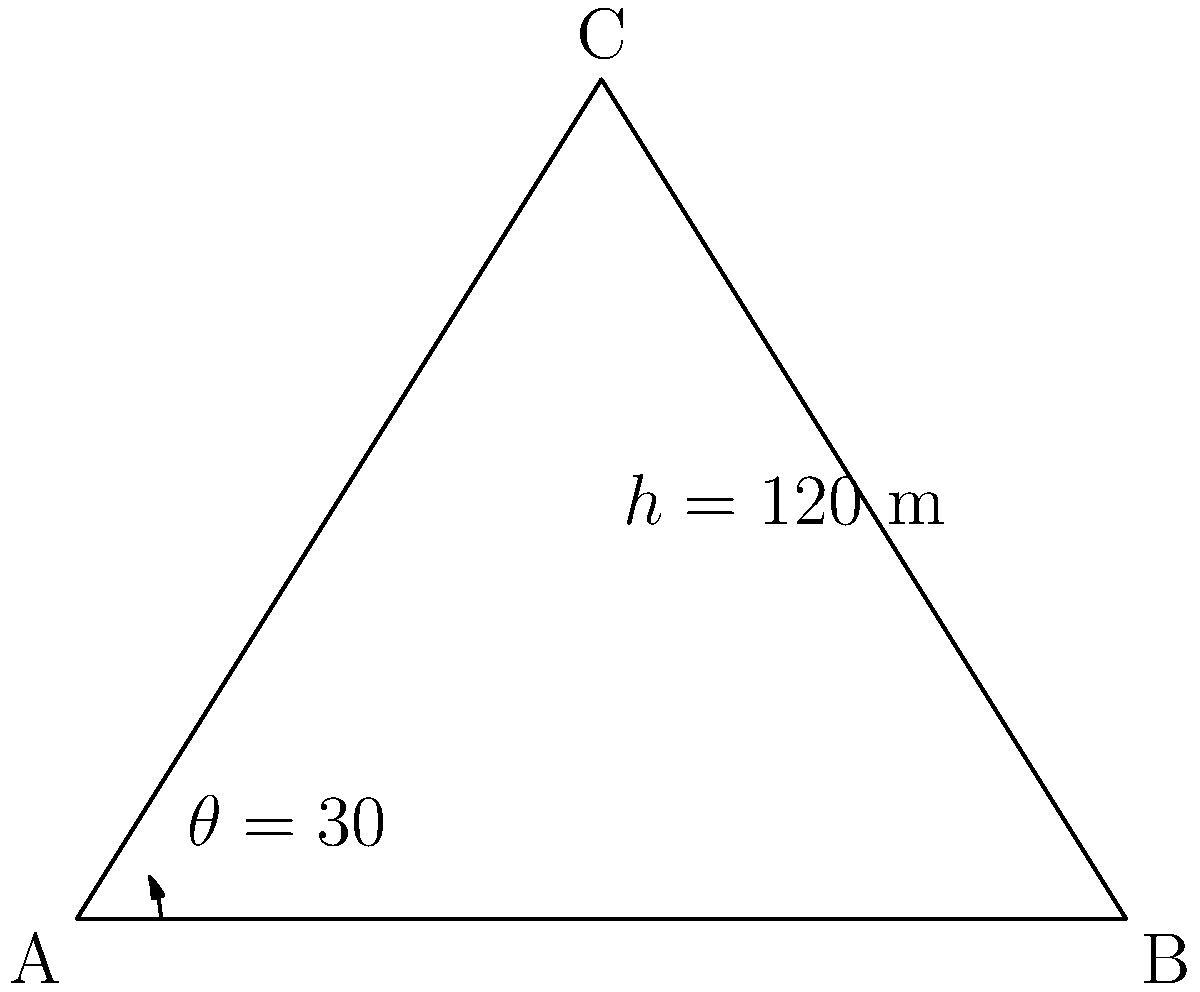As a successful entrepreneur, you're overseeing the construction of a new bridge for your latest development project. The bridge's support structure forms a triangle, where the tower height ($h$) is 120 meters, and the angle ($\theta$) between the support cable and the horizontal is 30°. What is the length of half the bridge span (the distance from the tower base to one end of the bridge)? Let's approach this step-by-step:

1) In this problem, we have a right triangle. The tower height forms the opposite side, half the bridge span forms the adjacent side, and the support cable forms the hypotenuse.

2) We know the angle $\theta = 30°$ and the opposite side (tower height) $h = 120$ meters.

3) To find the adjacent side (half the bridge span), we can use the tangent function:

   $\tan \theta = \frac{\text{opposite}}{\text{adjacent}}$

4) Substituting our known values:

   $\tan 30° = \frac{120}{\text{adjacent}}$

5) We know that $\tan 30° = \frac{1}{\sqrt{3}}$, so:

   $\frac{1}{\sqrt{3}} = \frac{120}{\text{adjacent}}$

6) Cross multiply:

   $\text{adjacent} = 120 \sqrt{3}$

7) Simplify:

   $\text{adjacent} \approx 207.85$ meters

Therefore, half the bridge span is approximately 207.85 meters.
Answer: 207.85 meters 